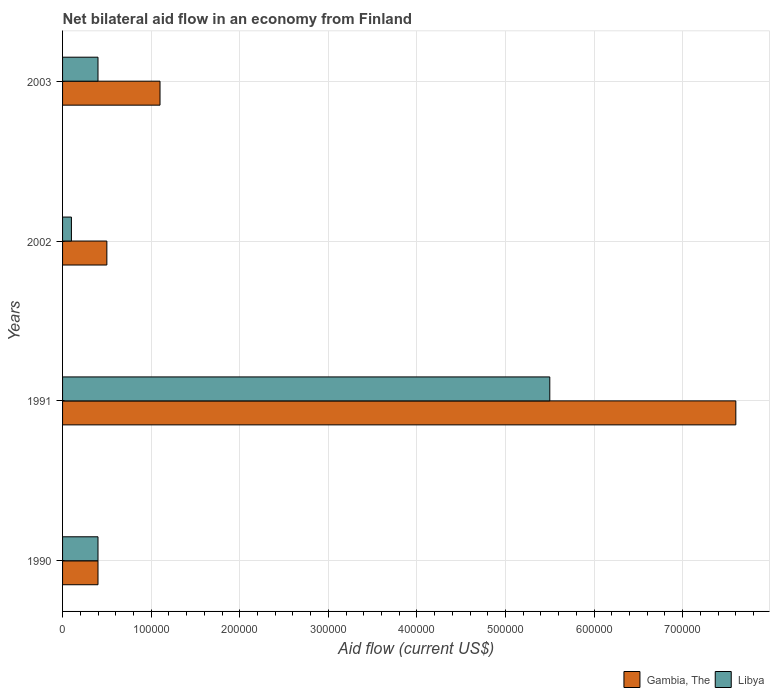How many groups of bars are there?
Make the answer very short. 4. Are the number of bars per tick equal to the number of legend labels?
Your answer should be compact. Yes. Are the number of bars on each tick of the Y-axis equal?
Make the answer very short. Yes. How many bars are there on the 2nd tick from the top?
Provide a succinct answer. 2. In how many cases, is the number of bars for a given year not equal to the number of legend labels?
Keep it short and to the point. 0. What is the net bilateral aid flow in Gambia, The in 1991?
Make the answer very short. 7.60e+05. Across all years, what is the maximum net bilateral aid flow in Gambia, The?
Give a very brief answer. 7.60e+05. In which year was the net bilateral aid flow in Libya minimum?
Your answer should be compact. 2002. What is the total net bilateral aid flow in Gambia, The in the graph?
Your answer should be very brief. 9.60e+05. What is the difference between the net bilateral aid flow in Libya in 1991 and that in 2003?
Your answer should be very brief. 5.10e+05. What is the average net bilateral aid flow in Gambia, The per year?
Provide a succinct answer. 2.40e+05. In how many years, is the net bilateral aid flow in Libya greater than 760000 US$?
Keep it short and to the point. 0. Is the net bilateral aid flow in Gambia, The in 1991 less than that in 2003?
Your response must be concise. No. Is the difference between the net bilateral aid flow in Gambia, The in 1990 and 2003 greater than the difference between the net bilateral aid flow in Libya in 1990 and 2003?
Your response must be concise. No. What is the difference between the highest and the second highest net bilateral aid flow in Gambia, The?
Ensure brevity in your answer.  6.50e+05. What is the difference between the highest and the lowest net bilateral aid flow in Gambia, The?
Give a very brief answer. 7.20e+05. In how many years, is the net bilateral aid flow in Gambia, The greater than the average net bilateral aid flow in Gambia, The taken over all years?
Keep it short and to the point. 1. Is the sum of the net bilateral aid flow in Gambia, The in 1990 and 2002 greater than the maximum net bilateral aid flow in Libya across all years?
Ensure brevity in your answer.  No. What does the 2nd bar from the top in 1990 represents?
Offer a terse response. Gambia, The. What does the 2nd bar from the bottom in 2002 represents?
Provide a succinct answer. Libya. How many bars are there?
Offer a terse response. 8. Are all the bars in the graph horizontal?
Offer a terse response. Yes. How many years are there in the graph?
Give a very brief answer. 4. Does the graph contain grids?
Make the answer very short. Yes. How are the legend labels stacked?
Your answer should be very brief. Horizontal. What is the title of the graph?
Offer a very short reply. Net bilateral aid flow in an economy from Finland. Does "Middle income" appear as one of the legend labels in the graph?
Offer a terse response. No. What is the Aid flow (current US$) in Gambia, The in 1991?
Provide a succinct answer. 7.60e+05. What is the Aid flow (current US$) in Gambia, The in 2003?
Provide a succinct answer. 1.10e+05. What is the Aid flow (current US$) of Libya in 2003?
Your answer should be very brief. 4.00e+04. Across all years, what is the maximum Aid flow (current US$) in Gambia, The?
Your answer should be very brief. 7.60e+05. Across all years, what is the maximum Aid flow (current US$) of Libya?
Give a very brief answer. 5.50e+05. What is the total Aid flow (current US$) in Gambia, The in the graph?
Your answer should be very brief. 9.60e+05. What is the total Aid flow (current US$) in Libya in the graph?
Your response must be concise. 6.40e+05. What is the difference between the Aid flow (current US$) in Gambia, The in 1990 and that in 1991?
Keep it short and to the point. -7.20e+05. What is the difference between the Aid flow (current US$) in Libya in 1990 and that in 1991?
Give a very brief answer. -5.10e+05. What is the difference between the Aid flow (current US$) of Libya in 1990 and that in 2002?
Your response must be concise. 3.00e+04. What is the difference between the Aid flow (current US$) of Libya in 1990 and that in 2003?
Ensure brevity in your answer.  0. What is the difference between the Aid flow (current US$) of Gambia, The in 1991 and that in 2002?
Provide a short and direct response. 7.10e+05. What is the difference between the Aid flow (current US$) in Libya in 1991 and that in 2002?
Ensure brevity in your answer.  5.40e+05. What is the difference between the Aid flow (current US$) in Gambia, The in 1991 and that in 2003?
Provide a succinct answer. 6.50e+05. What is the difference between the Aid flow (current US$) of Libya in 1991 and that in 2003?
Offer a terse response. 5.10e+05. What is the difference between the Aid flow (current US$) of Gambia, The in 1990 and the Aid flow (current US$) of Libya in 1991?
Give a very brief answer. -5.10e+05. What is the difference between the Aid flow (current US$) of Gambia, The in 1991 and the Aid flow (current US$) of Libya in 2002?
Keep it short and to the point. 7.50e+05. What is the difference between the Aid flow (current US$) in Gambia, The in 1991 and the Aid flow (current US$) in Libya in 2003?
Your answer should be very brief. 7.20e+05. What is the average Aid flow (current US$) in Gambia, The per year?
Make the answer very short. 2.40e+05. What is the average Aid flow (current US$) in Libya per year?
Your answer should be very brief. 1.60e+05. In the year 1991, what is the difference between the Aid flow (current US$) in Gambia, The and Aid flow (current US$) in Libya?
Your response must be concise. 2.10e+05. What is the ratio of the Aid flow (current US$) of Gambia, The in 1990 to that in 1991?
Provide a succinct answer. 0.05. What is the ratio of the Aid flow (current US$) in Libya in 1990 to that in 1991?
Provide a succinct answer. 0.07. What is the ratio of the Aid flow (current US$) of Libya in 1990 to that in 2002?
Keep it short and to the point. 4. What is the ratio of the Aid flow (current US$) in Gambia, The in 1990 to that in 2003?
Your response must be concise. 0.36. What is the ratio of the Aid flow (current US$) of Libya in 1990 to that in 2003?
Offer a very short reply. 1. What is the ratio of the Aid flow (current US$) in Gambia, The in 1991 to that in 2003?
Ensure brevity in your answer.  6.91. What is the ratio of the Aid flow (current US$) in Libya in 1991 to that in 2003?
Provide a short and direct response. 13.75. What is the ratio of the Aid flow (current US$) of Gambia, The in 2002 to that in 2003?
Offer a very short reply. 0.45. What is the ratio of the Aid flow (current US$) in Libya in 2002 to that in 2003?
Ensure brevity in your answer.  0.25. What is the difference between the highest and the second highest Aid flow (current US$) of Gambia, The?
Ensure brevity in your answer.  6.50e+05. What is the difference between the highest and the second highest Aid flow (current US$) in Libya?
Offer a terse response. 5.10e+05. What is the difference between the highest and the lowest Aid flow (current US$) in Gambia, The?
Offer a terse response. 7.20e+05. What is the difference between the highest and the lowest Aid flow (current US$) of Libya?
Your answer should be very brief. 5.40e+05. 